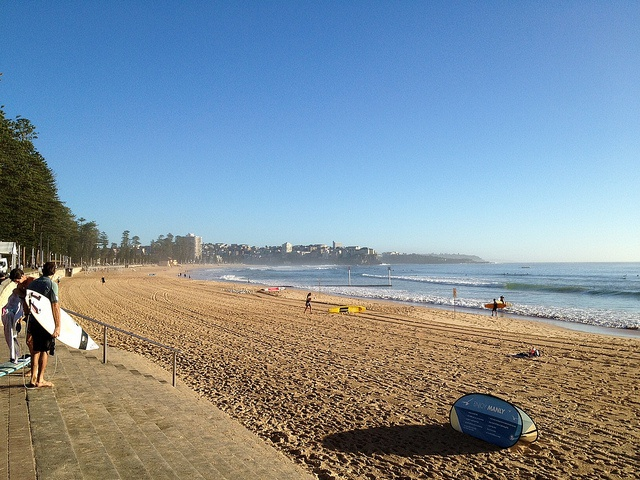Describe the objects in this image and their specific colors. I can see people in teal, black, tan, and maroon tones, surfboard in teal, white, black, tan, and gray tones, people in teal, black, maroon, and tan tones, surfboard in teal, darkgray, ivory, black, and gray tones, and surfboard in teal, orange, gold, and olive tones in this image. 